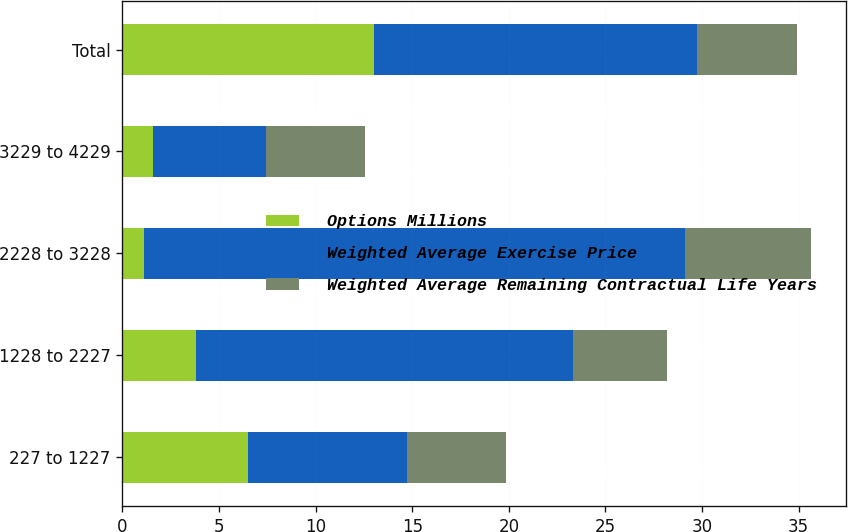<chart> <loc_0><loc_0><loc_500><loc_500><stacked_bar_chart><ecel><fcel>227 to 1227<fcel>1228 to 2227<fcel>2228 to 3228<fcel>3229 to 4229<fcel>Total<nl><fcel>Options Millions<fcel>6.5<fcel>3.8<fcel>1.1<fcel>1.6<fcel>13<nl><fcel>Weighted Average Exercise Price<fcel>8.24<fcel>19.5<fcel>28.04<fcel>5.85<fcel>16.73<nl><fcel>Weighted Average Remaining Contractual Life Years<fcel>5.1<fcel>4.9<fcel>6.5<fcel>5.1<fcel>5.2<nl></chart> 